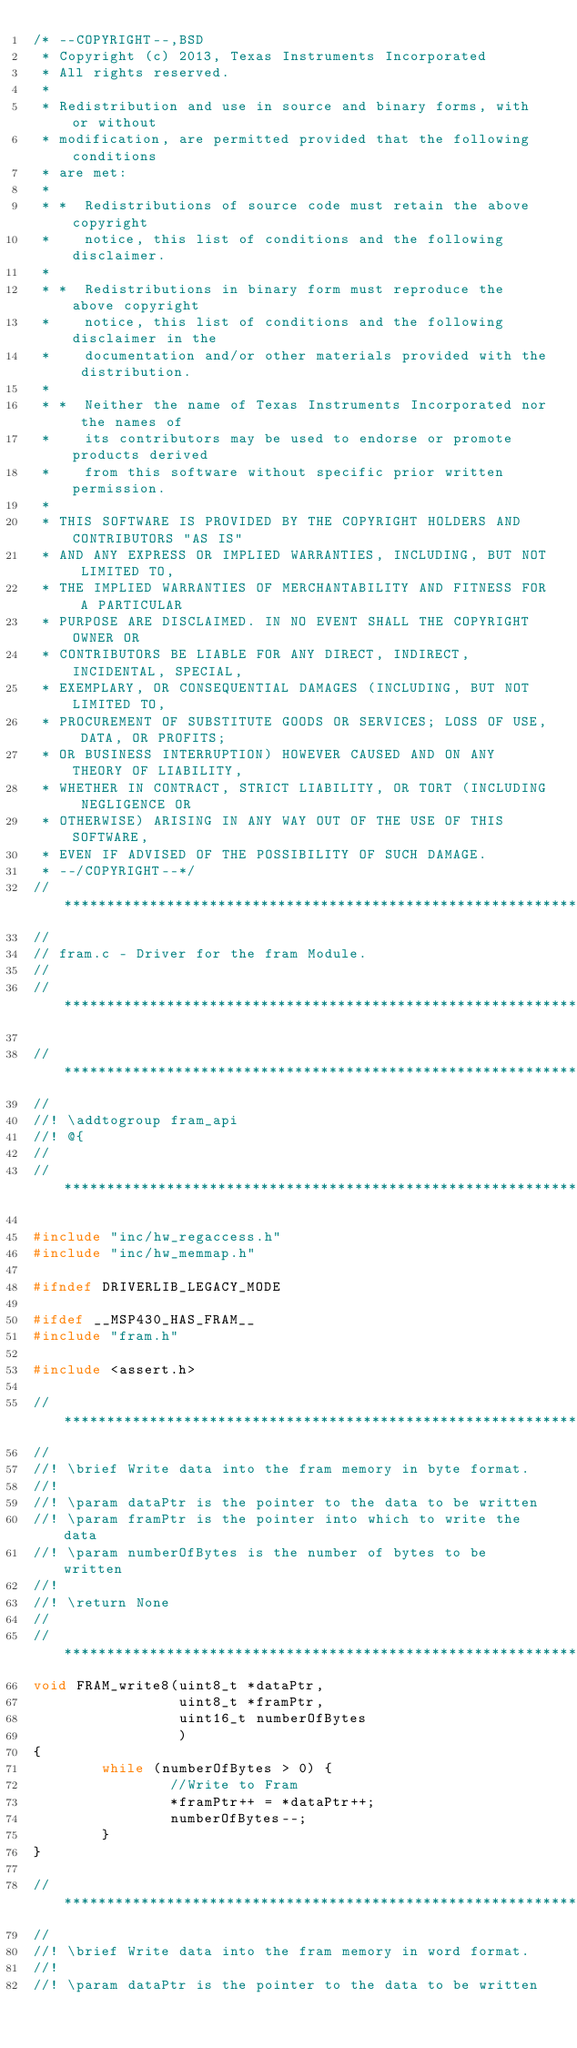<code> <loc_0><loc_0><loc_500><loc_500><_C_>/* --COPYRIGHT--,BSD
 * Copyright (c) 2013, Texas Instruments Incorporated
 * All rights reserved.
 *
 * Redistribution and use in source and binary forms, with or without
 * modification, are permitted provided that the following conditions
 * are met:
 *
 * *  Redistributions of source code must retain the above copyright
 *    notice, this list of conditions and the following disclaimer.
 *
 * *  Redistributions in binary form must reproduce the above copyright
 *    notice, this list of conditions and the following disclaimer in the
 *    documentation and/or other materials provided with the distribution.
 *
 * *  Neither the name of Texas Instruments Incorporated nor the names of
 *    its contributors may be used to endorse or promote products derived
 *    from this software without specific prior written permission.
 *
 * THIS SOFTWARE IS PROVIDED BY THE COPYRIGHT HOLDERS AND CONTRIBUTORS "AS IS"
 * AND ANY EXPRESS OR IMPLIED WARRANTIES, INCLUDING, BUT NOT LIMITED TO,
 * THE IMPLIED WARRANTIES OF MERCHANTABILITY AND FITNESS FOR A PARTICULAR
 * PURPOSE ARE DISCLAIMED. IN NO EVENT SHALL THE COPYRIGHT OWNER OR
 * CONTRIBUTORS BE LIABLE FOR ANY DIRECT, INDIRECT, INCIDENTAL, SPECIAL,
 * EXEMPLARY, OR CONSEQUENTIAL DAMAGES (INCLUDING, BUT NOT LIMITED TO,
 * PROCUREMENT OF SUBSTITUTE GOODS OR SERVICES; LOSS OF USE, DATA, OR PROFITS;
 * OR BUSINESS INTERRUPTION) HOWEVER CAUSED AND ON ANY THEORY OF LIABILITY,
 * WHETHER IN CONTRACT, STRICT LIABILITY, OR TORT (INCLUDING NEGLIGENCE OR
 * OTHERWISE) ARISING IN ANY WAY OUT OF THE USE OF THIS SOFTWARE,
 * EVEN IF ADVISED OF THE POSSIBILITY OF SUCH DAMAGE.
 * --/COPYRIGHT--*/
//*****************************************************************************
//
// fram.c - Driver for the fram Module.
//
//*****************************************************************************

//*****************************************************************************
//
//! \addtogroup fram_api
//! @{
//
//*****************************************************************************

#include "inc/hw_regaccess.h"
#include "inc/hw_memmap.h"

#ifndef DRIVERLIB_LEGACY_MODE

#ifdef __MSP430_HAS_FRAM__
#include "fram.h"

#include <assert.h>

//*****************************************************************************
//
//! \brief Write data into the fram memory in byte format.
//!
//! \param dataPtr is the pointer to the data to be written
//! \param framPtr is the pointer into which to write the data
//! \param numberOfBytes is the number of bytes to be written
//!
//! \return None
//
//*****************************************************************************
void FRAM_write8(uint8_t *dataPtr,
                 uint8_t *framPtr,
                 uint16_t numberOfBytes
                 )
{
        while (numberOfBytes > 0) {
                //Write to Fram
                *framPtr++ = *dataPtr++;
                numberOfBytes--;
        }
}

//*****************************************************************************
//
//! \brief Write data into the fram memory in word format.
//!
//! \param dataPtr is the pointer to the data to be written</code> 